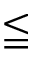Convert formula to latex. <formula><loc_0><loc_0><loc_500><loc_500>\leqq</formula> 